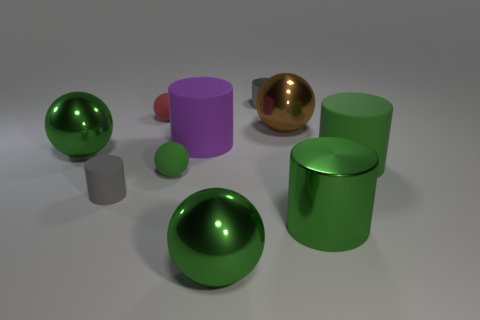There is a green metallic sphere that is in front of the green rubber sphere; how big is it?
Offer a terse response. Large. What number of matte balls are the same color as the tiny metal thing?
Give a very brief answer. 0. How many cubes are either tiny gray matte objects or gray things?
Ensure brevity in your answer.  0. What shape is the object that is behind the gray rubber object and left of the tiny red rubber sphere?
Keep it short and to the point. Sphere. Are there any green rubber cylinders that have the same size as the red thing?
Your answer should be compact. No. What number of things are big purple things that are behind the green matte sphere or large brown metal cylinders?
Give a very brief answer. 1. Is the large brown object made of the same material as the tiny gray thing that is in front of the gray metallic thing?
Make the answer very short. No. What number of other things are there of the same shape as the big green matte object?
Offer a terse response. 4. What number of things are either objects that are to the right of the brown sphere or metal cylinders that are in front of the gray rubber thing?
Provide a short and direct response. 2. How many other things are there of the same color as the small shiny object?
Make the answer very short. 1. 